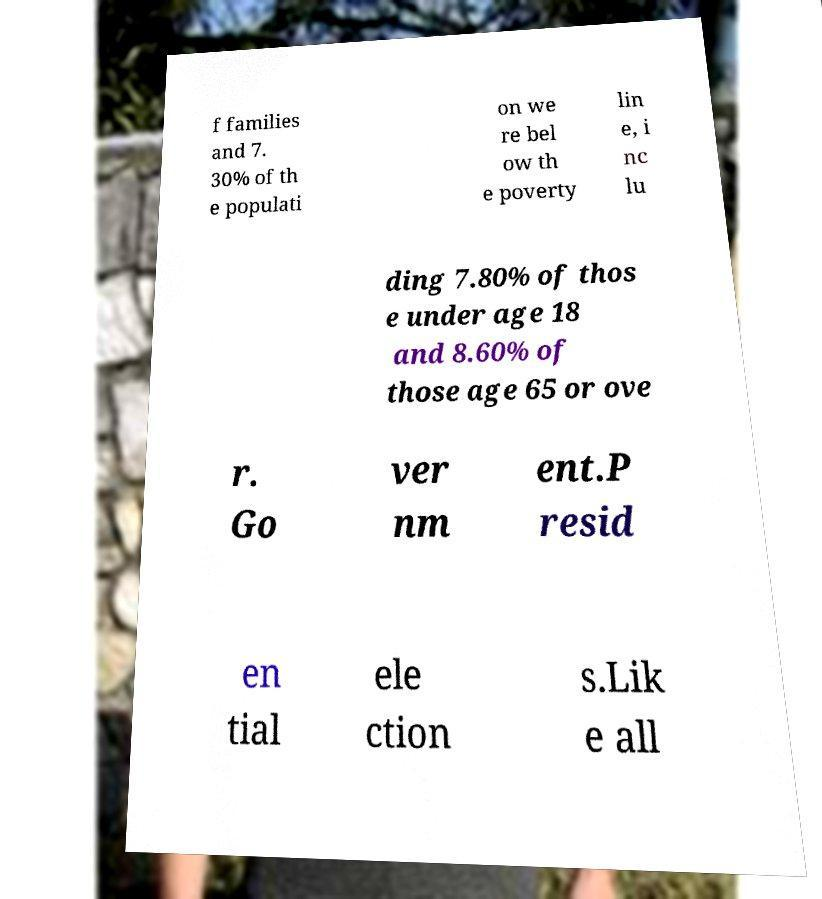Can you read and provide the text displayed in the image?This photo seems to have some interesting text. Can you extract and type it out for me? f families and 7. 30% of th e populati on we re bel ow th e poverty lin e, i nc lu ding 7.80% of thos e under age 18 and 8.60% of those age 65 or ove r. Go ver nm ent.P resid en tial ele ction s.Lik e all 